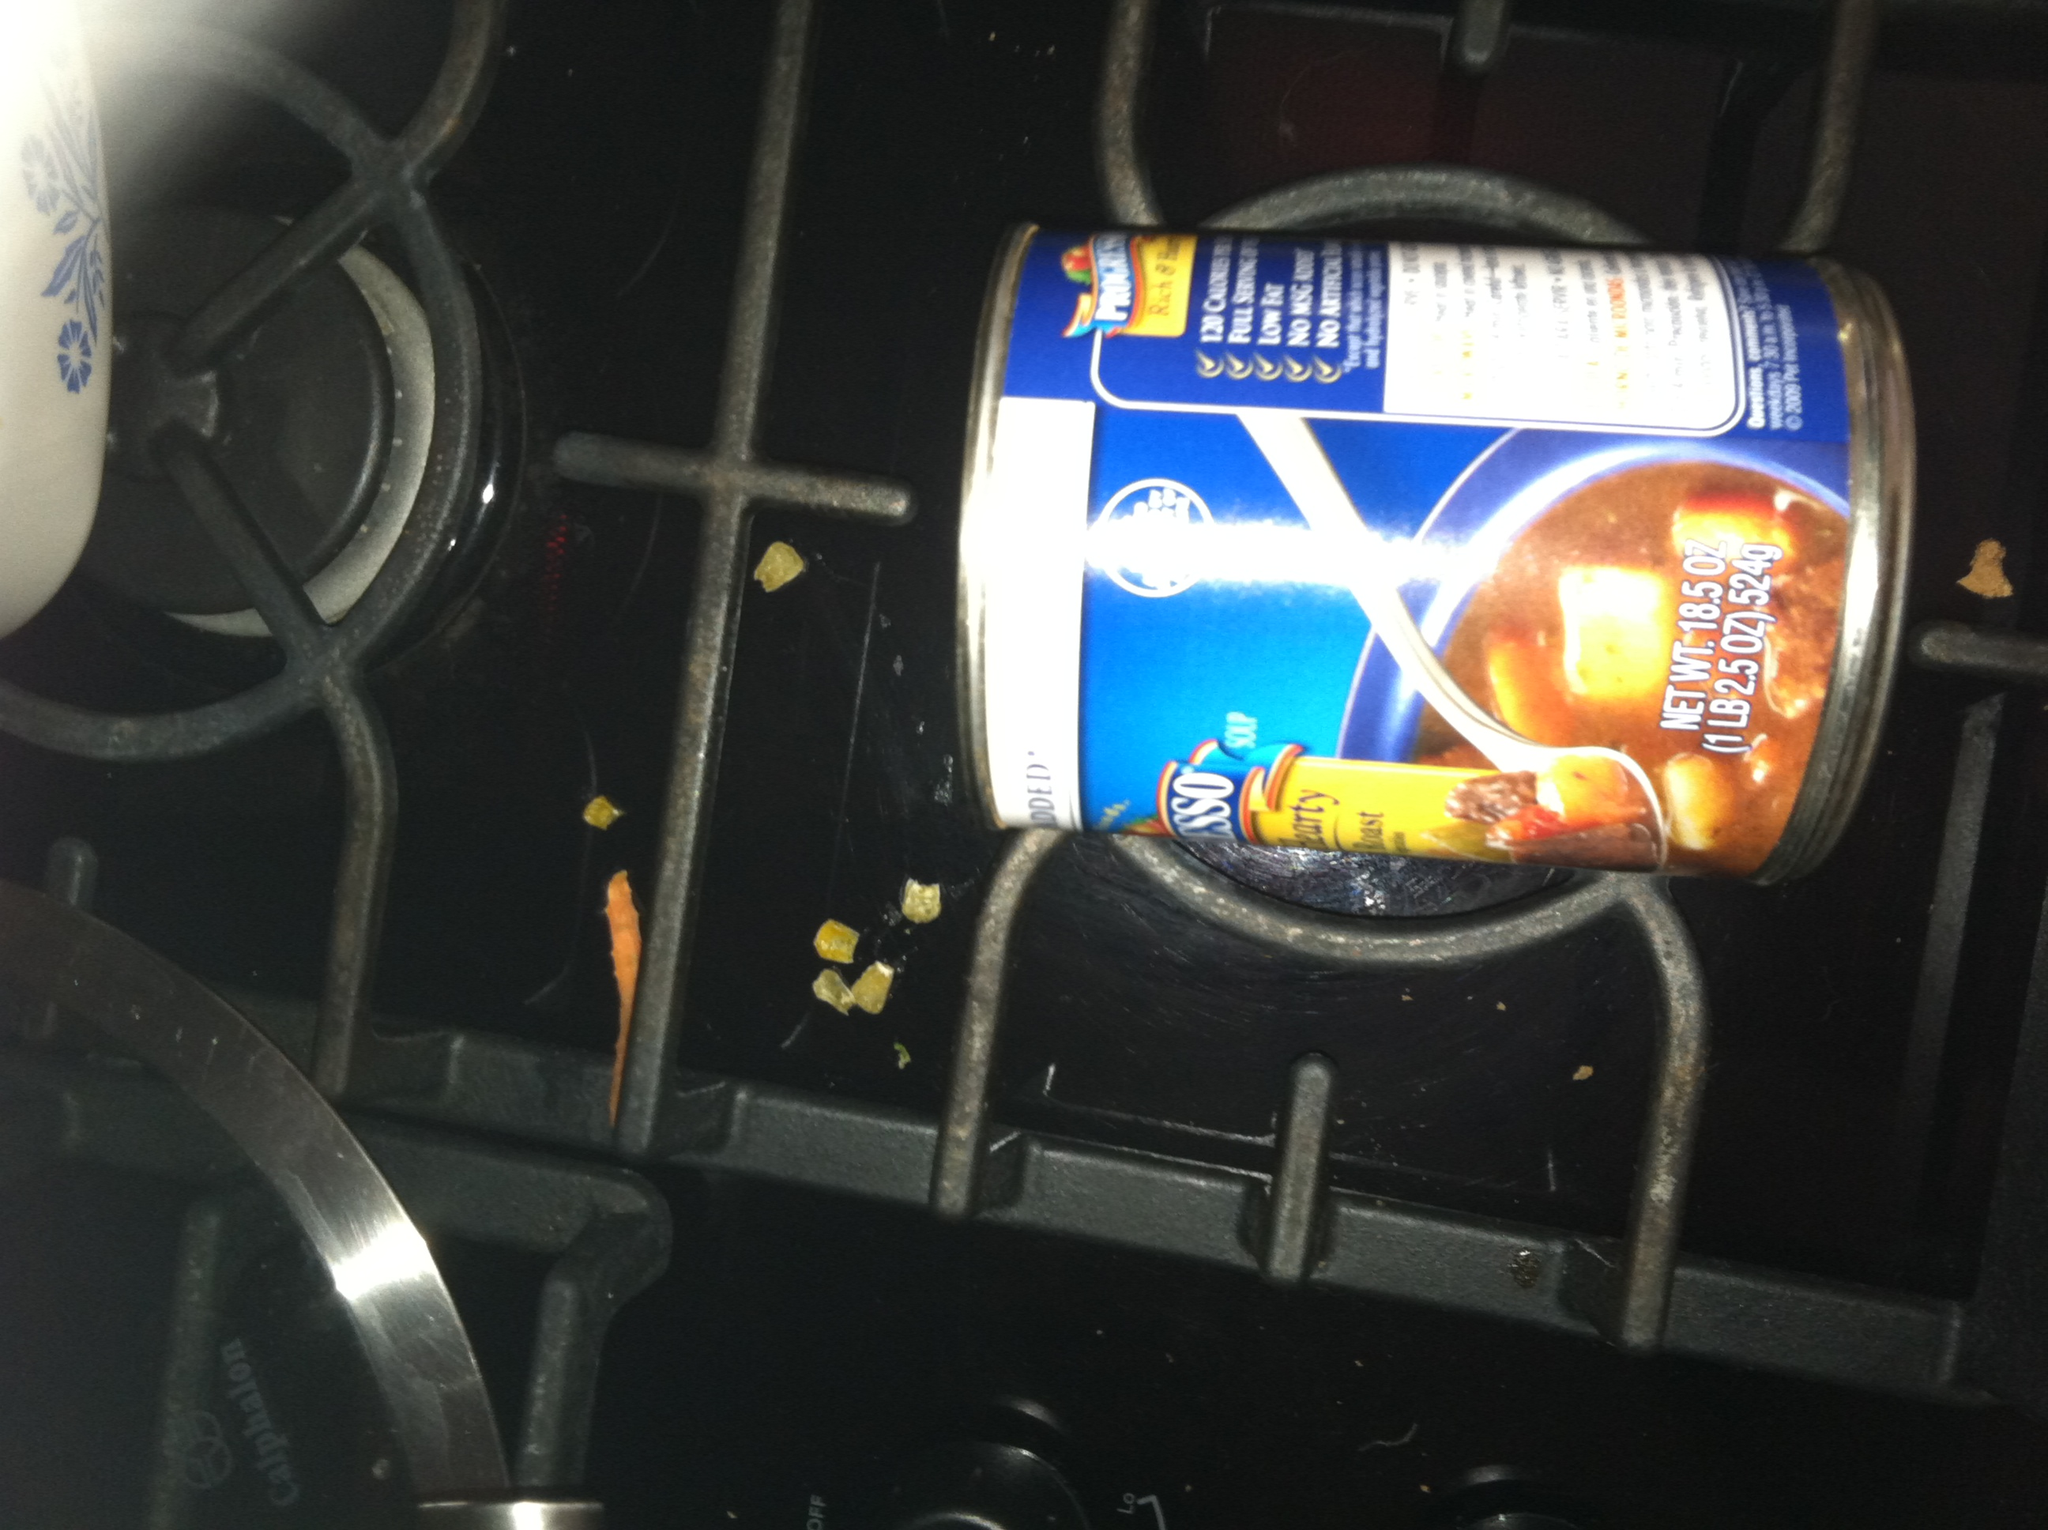Imagine this can of soup is the last remaining food on Earth. How would you make it last as long as possible? If this can of soup were the last remaining food on Earth, here are some strategies to make it last as long as possible:
1. Rationing: Divide the soup into small portions and consume it sparingly, possibly just enough to meet your daily caloric needs.
2. Adding Water: Dilute the soup with water, increasing the volume and spreading the nutrients further.
3. Supplementing: Gather edible plants, roots, and small insects as additional sources of nutrients to supplement the soup.
4. Preservation: Store the soup in a cool, dark place to prevent spoilage.
5. Sharing: If in a community, create a shared system where everyone gets an equal ration to ensure fairness and avoid wasting any soup.
Careful management and creativity in supplementing nutrients will help in surviving longer with the limited resource. Describe an everyday realistic scenario that could occur with this soup can in a modern kitchen. In a modern kitchen, a typical scenario with this can of soup might be a busy weekday evening. Alex, hurrying home from work, realized they had little time to cook a complicated meal. They grabbed the can off the shelf, opened it with a can opener, and poured the contents into a pot on the stove. As the soup heated up, they toasted a slice of bread, cut up some fresh vegetables for a quick salad, and set the table for dinner. Once the soup was heated through, they served it in a bowl, garnished it with a sprinkle of shredded cheese and some chopped herbs, and sat down to enjoy a quick, warm, and satisfying meal before settling down for the evening's activities. 